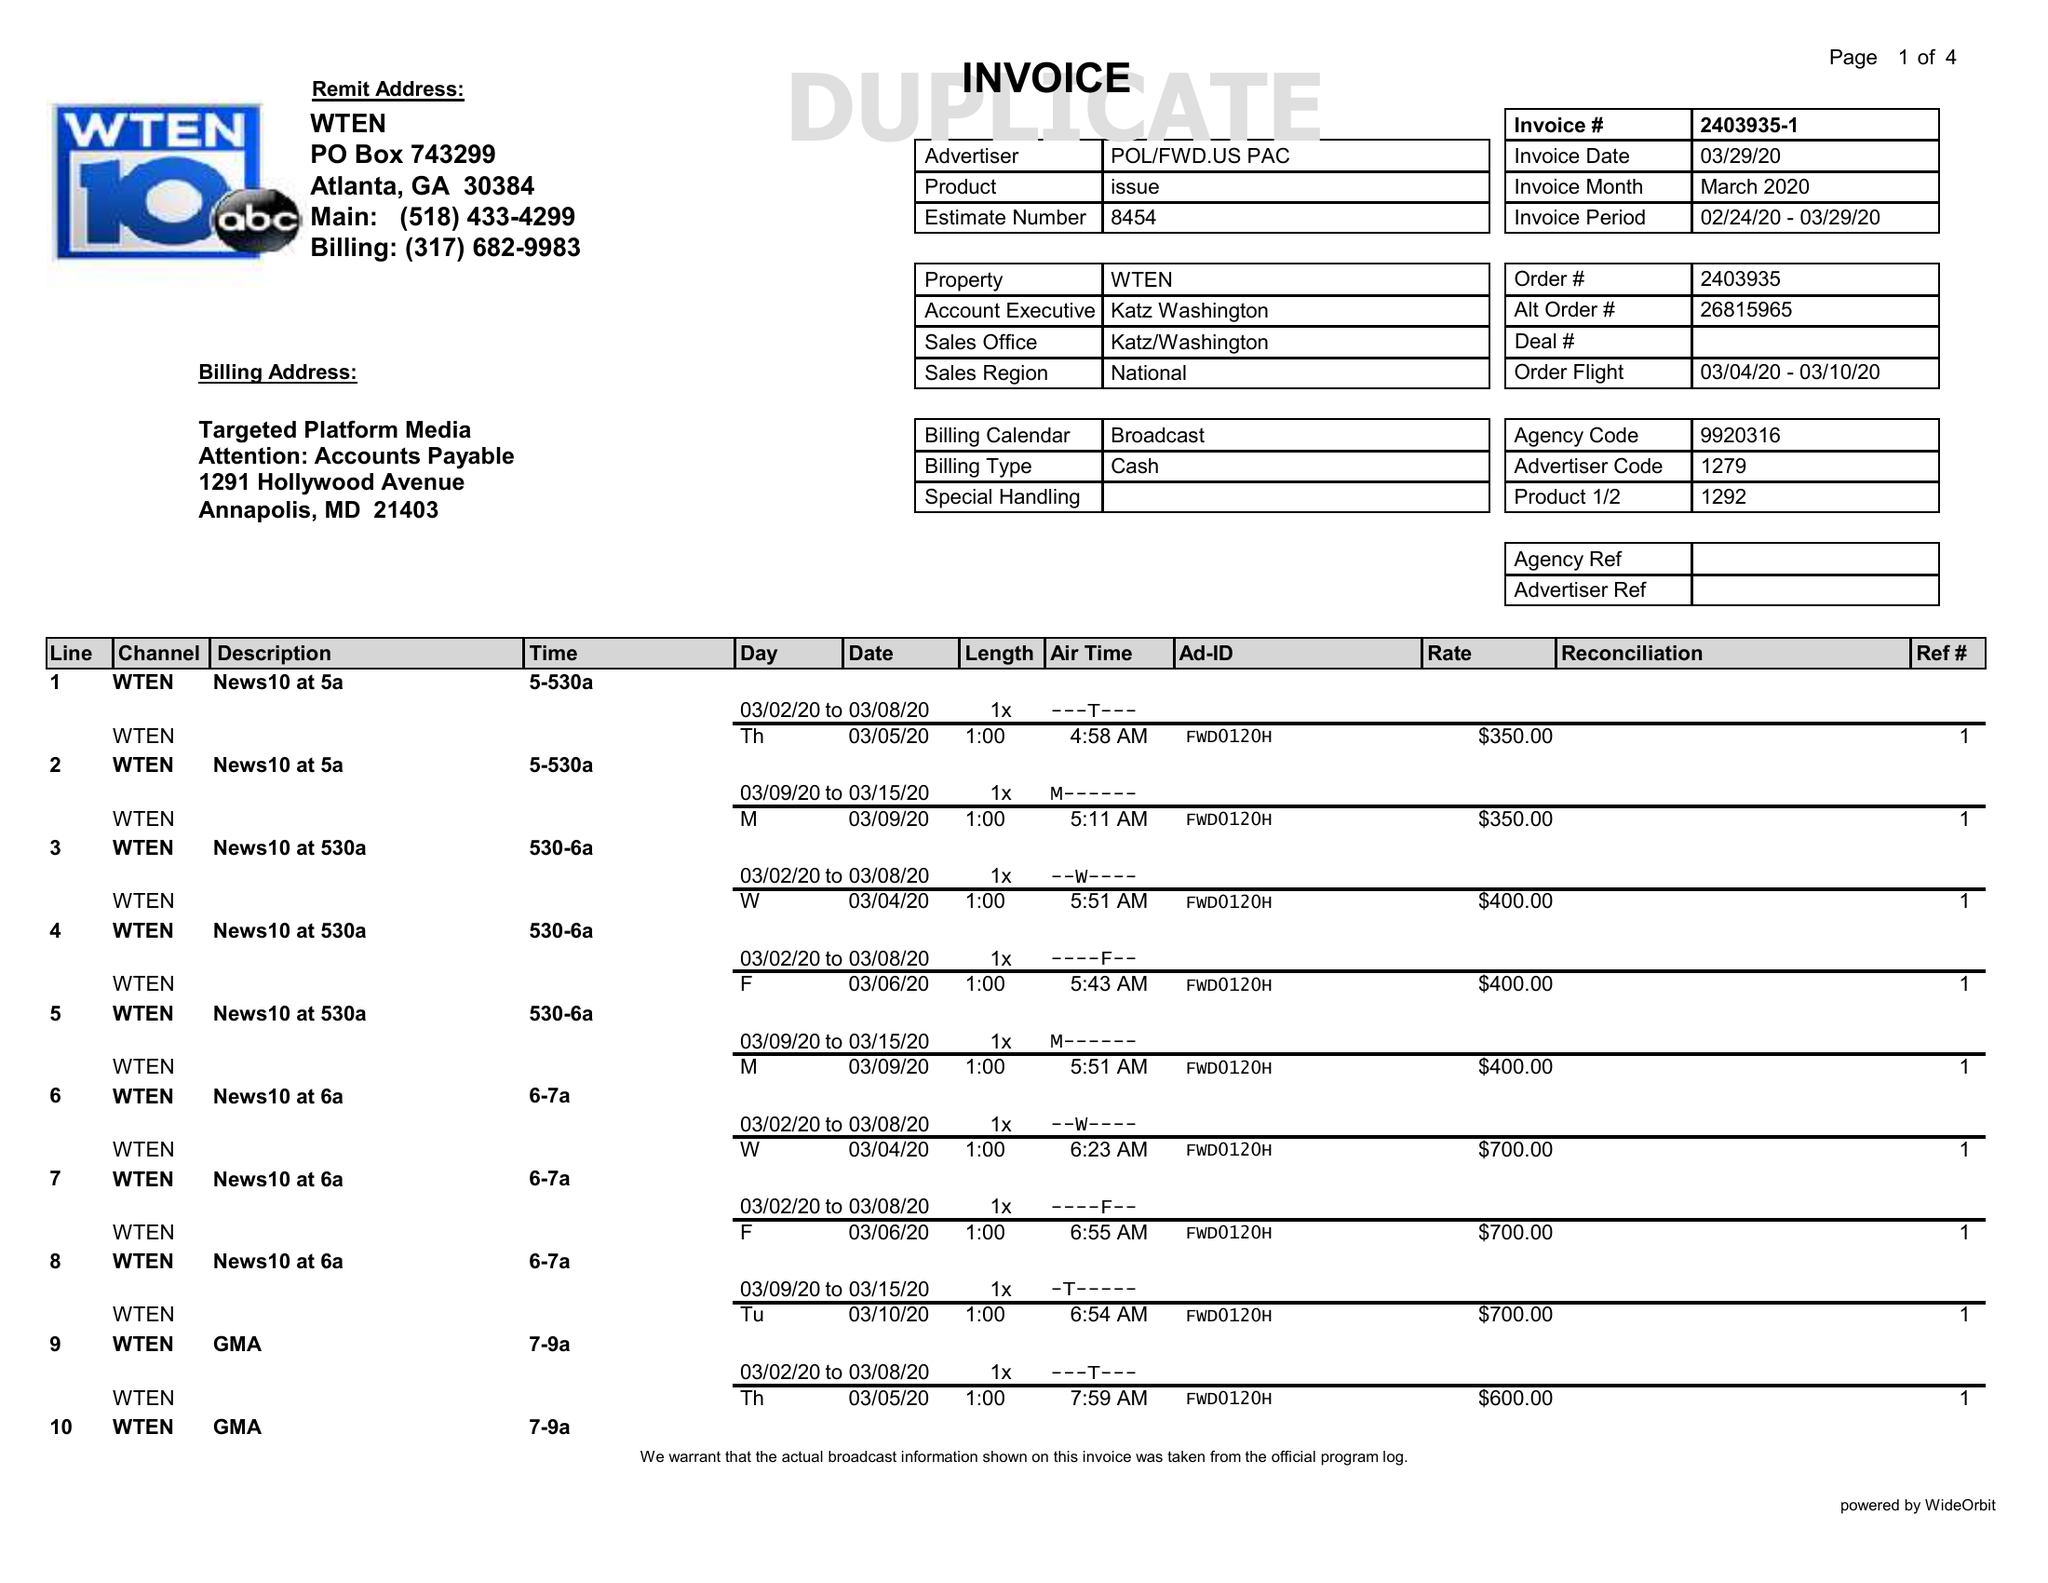What is the value for the gross_amount?
Answer the question using a single word or phrase. 34840.00 